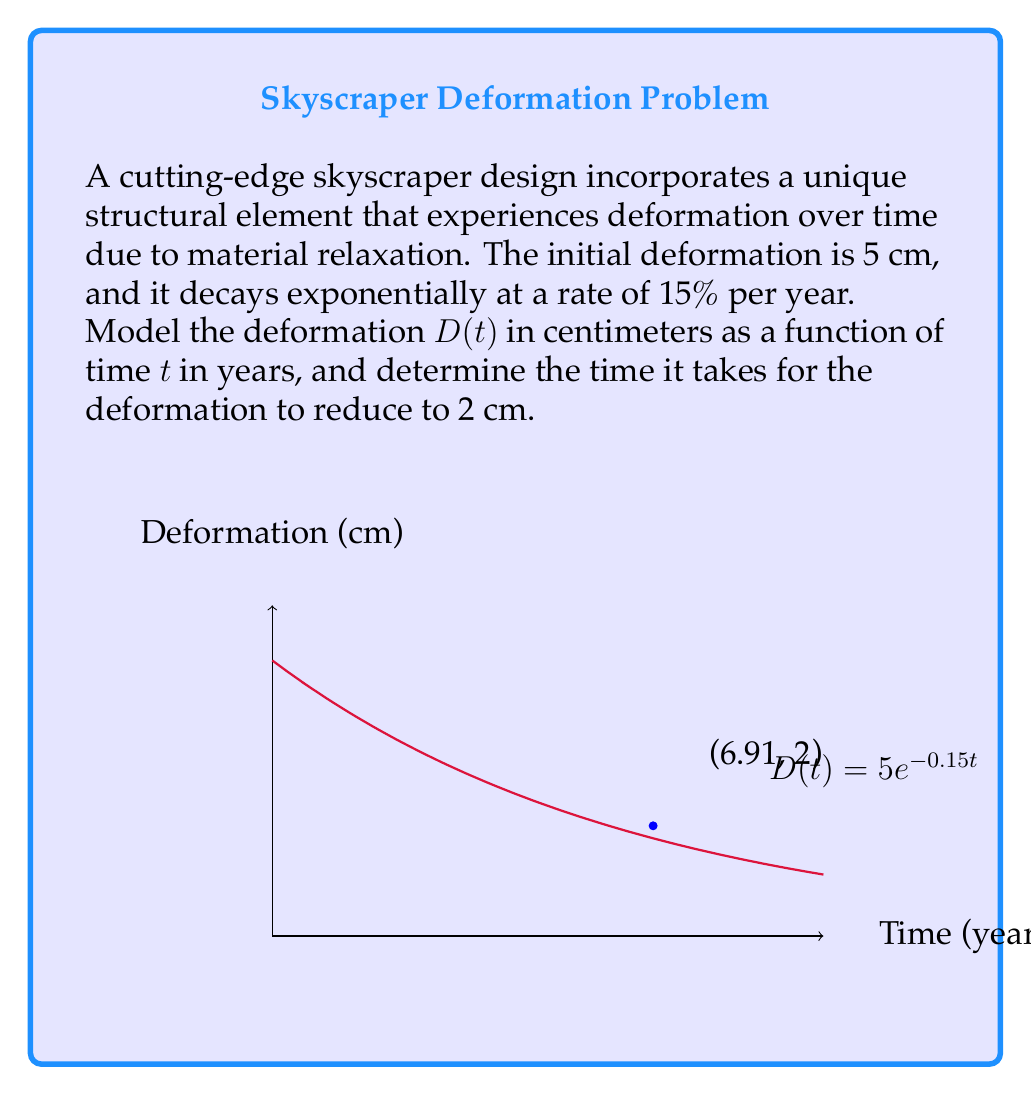Teach me how to tackle this problem. 1) The general form of exponential decay is:
   $$D(t) = D_0 e^{-kt}$$
   where $D_0$ is the initial deformation and $k$ is the decay rate.

2) Given:
   - Initial deformation $D_0 = 5$ cm
   - Decay rate = 15% per year = 0.15 per year

3) Substituting these values:
   $$D(t) = 5e^{-0.15t}$$

4) To find when the deformation reduces to 2 cm, we solve:
   $$2 = 5e^{-0.15t}$$

5) Dividing both sides by 5:
   $$\frac{2}{5} = e^{-0.15t}$$

6) Taking natural logarithm of both sides:
   $$\ln(\frac{2}{5}) = -0.15t$$

7) Solving for t:
   $$t = \frac{\ln(\frac{2}{5})}{-0.15} = \frac{\ln(0.4)}{-0.15}$$

8) Calculating:
   $$t \approx 6.91 \text{ years}$$
Answer: $D(t) = 5e^{-0.15t}$; 6.91 years 